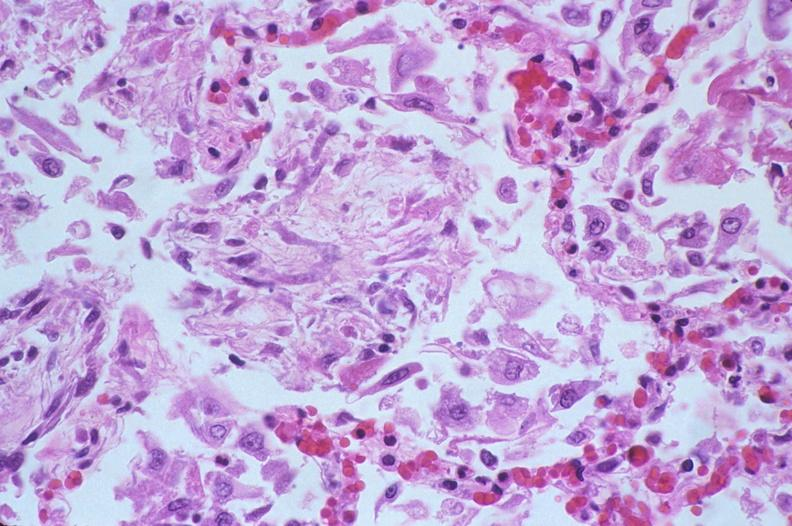s sickle cell disease present?
Answer the question using a single word or phrase. No 